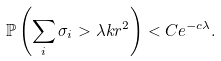<formula> <loc_0><loc_0><loc_500><loc_500>\mathbb { P } \left ( \sum _ { i } \sigma _ { i } > \lambda k r ^ { 2 } \right ) < C e ^ { - c \lambda } .</formula> 